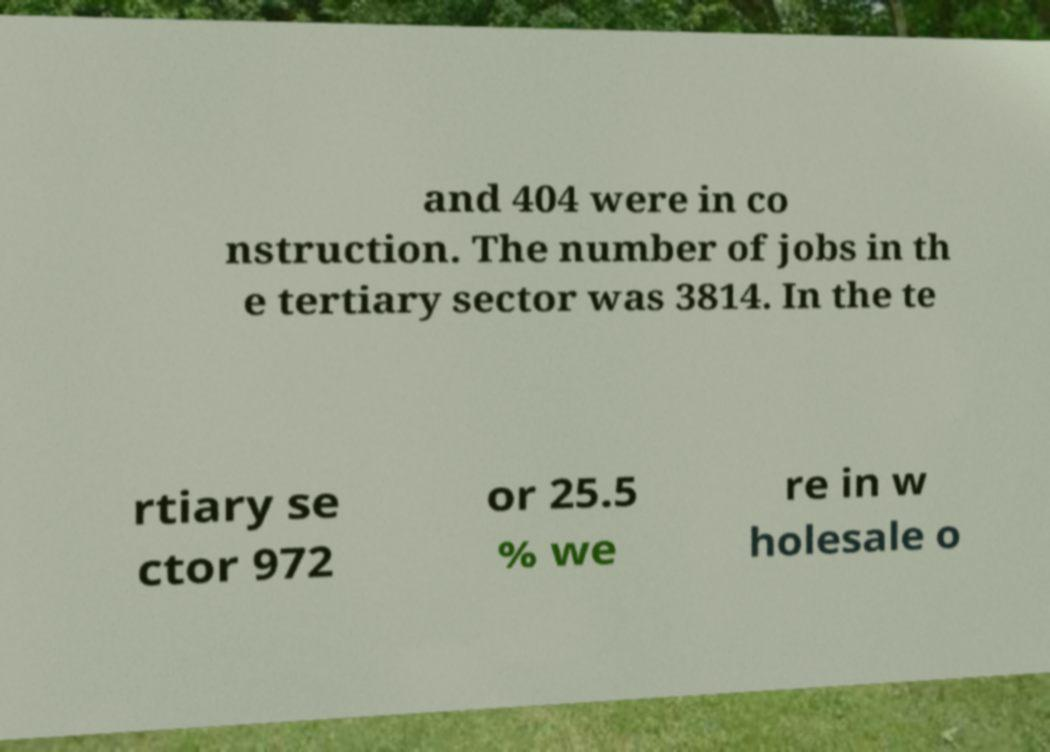What messages or text are displayed in this image? I need them in a readable, typed format. and 404 were in co nstruction. The number of jobs in th e tertiary sector was 3814. In the te rtiary se ctor 972 or 25.5 % we re in w holesale o 